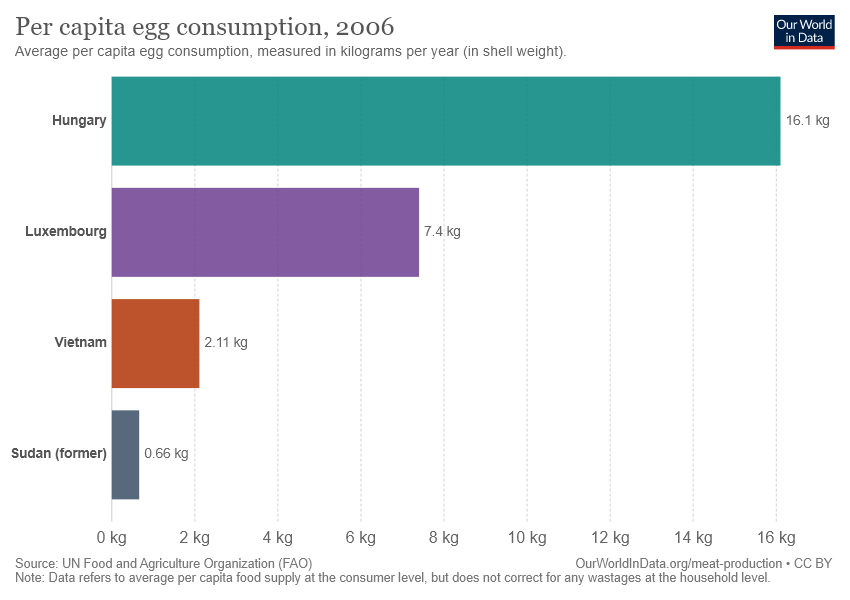Highlight a few significant elements in this photo. The difference in the average egg consumption between the highest and lowest consuming countries is 15.44 eggs per year. The highest egg-consuming country in the chart is Hungary. 